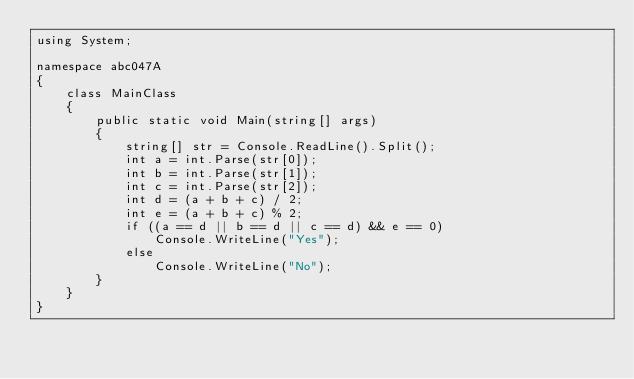<code> <loc_0><loc_0><loc_500><loc_500><_C#_>using System;

namespace abc047A
{
    class MainClass
    {
        public static void Main(string[] args)
        {
            string[] str = Console.ReadLine().Split();
            int a = int.Parse(str[0]);
            int b = int.Parse(str[1]);
            int c = int.Parse(str[2]);
            int d = (a + b + c) / 2;
            int e = (a + b + c) % 2;
            if ((a == d || b == d || c == d) && e == 0)
                Console.WriteLine("Yes");
            else
                Console.WriteLine("No");
        }
    }
}
</code> 